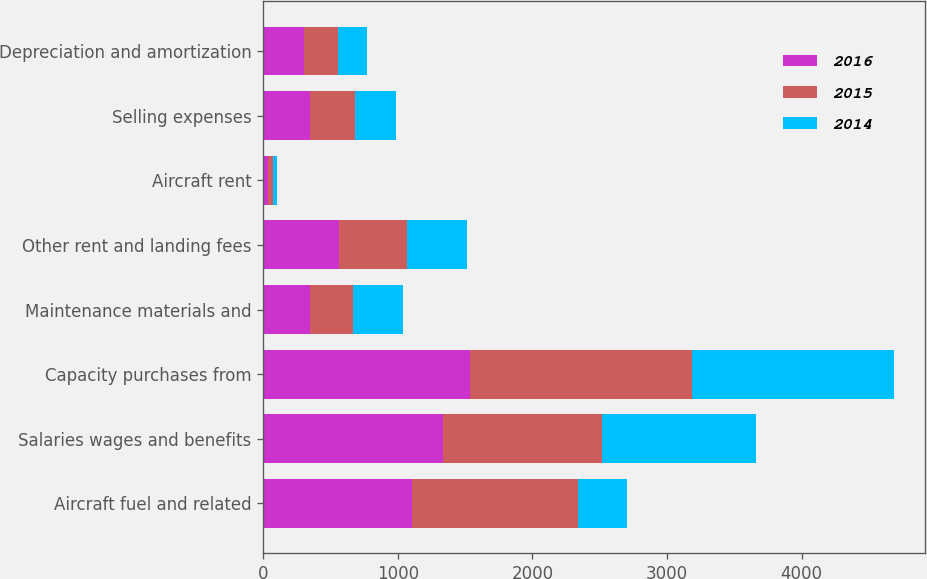Convert chart. <chart><loc_0><loc_0><loc_500><loc_500><stacked_bar_chart><ecel><fcel>Aircraft fuel and related<fcel>Salaries wages and benefits<fcel>Capacity purchases from<fcel>Maintenance materials and<fcel>Other rent and landing fees<fcel>Aircraft rent<fcel>Selling expenses<fcel>Depreciation and amortization<nl><fcel>2016<fcel>1109<fcel>1333<fcel>1538<fcel>345<fcel>564<fcel>36<fcel>347<fcel>301<nl><fcel>2015<fcel>1230<fcel>1187<fcel>1651<fcel>323<fcel>504<fcel>34<fcel>333<fcel>252<nl><fcel>2014<fcel>367<fcel>1140<fcel>1494<fcel>367<fcel>444<fcel>35<fcel>307<fcel>217<nl></chart> 